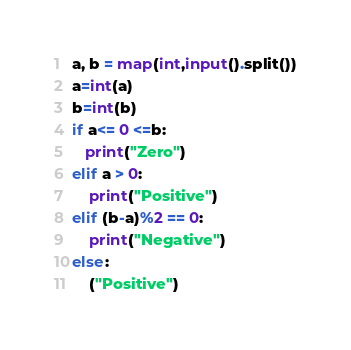Convert code to text. <code><loc_0><loc_0><loc_500><loc_500><_Python_>a, b = map(int,input().split())
a=int(a)
b=int(b)
if a<= 0 <=b:
   print("Zero")
elif a > 0:
    print("Positive")
elif (b-a)%2 == 0:
    print("Negative")
else:
    ("Positive")</code> 